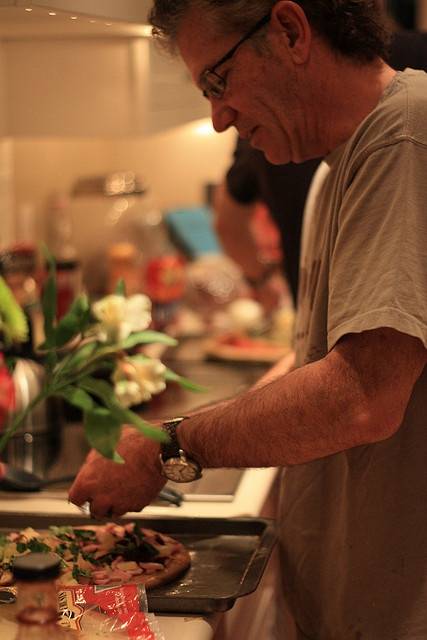Describe the objects in this image and their specific colors. I can see people in brown, maroon, and black tones, pizza in brown, black, and maroon tones, people in brown, black, maroon, gray, and tan tones, bottle in brown, maroon, and black tones, and bottle in brown, maroon, and tan tones in this image. 